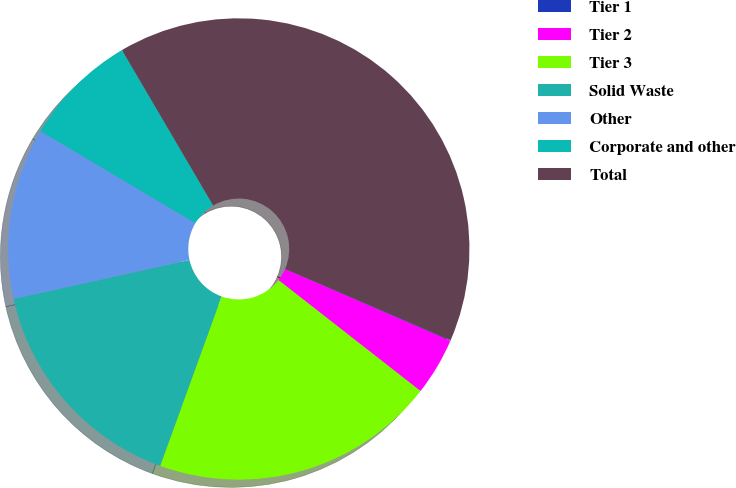Convert chart to OTSL. <chart><loc_0><loc_0><loc_500><loc_500><pie_chart><fcel>Tier 1<fcel>Tier 2<fcel>Tier 3<fcel>Solid Waste<fcel>Other<fcel>Corporate and other<fcel>Total<nl><fcel>0.05%<fcel>4.04%<fcel>19.98%<fcel>15.99%<fcel>12.01%<fcel>8.02%<fcel>39.91%<nl></chart> 